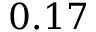<formula> <loc_0><loc_0><loc_500><loc_500>0 . 1 7</formula> 